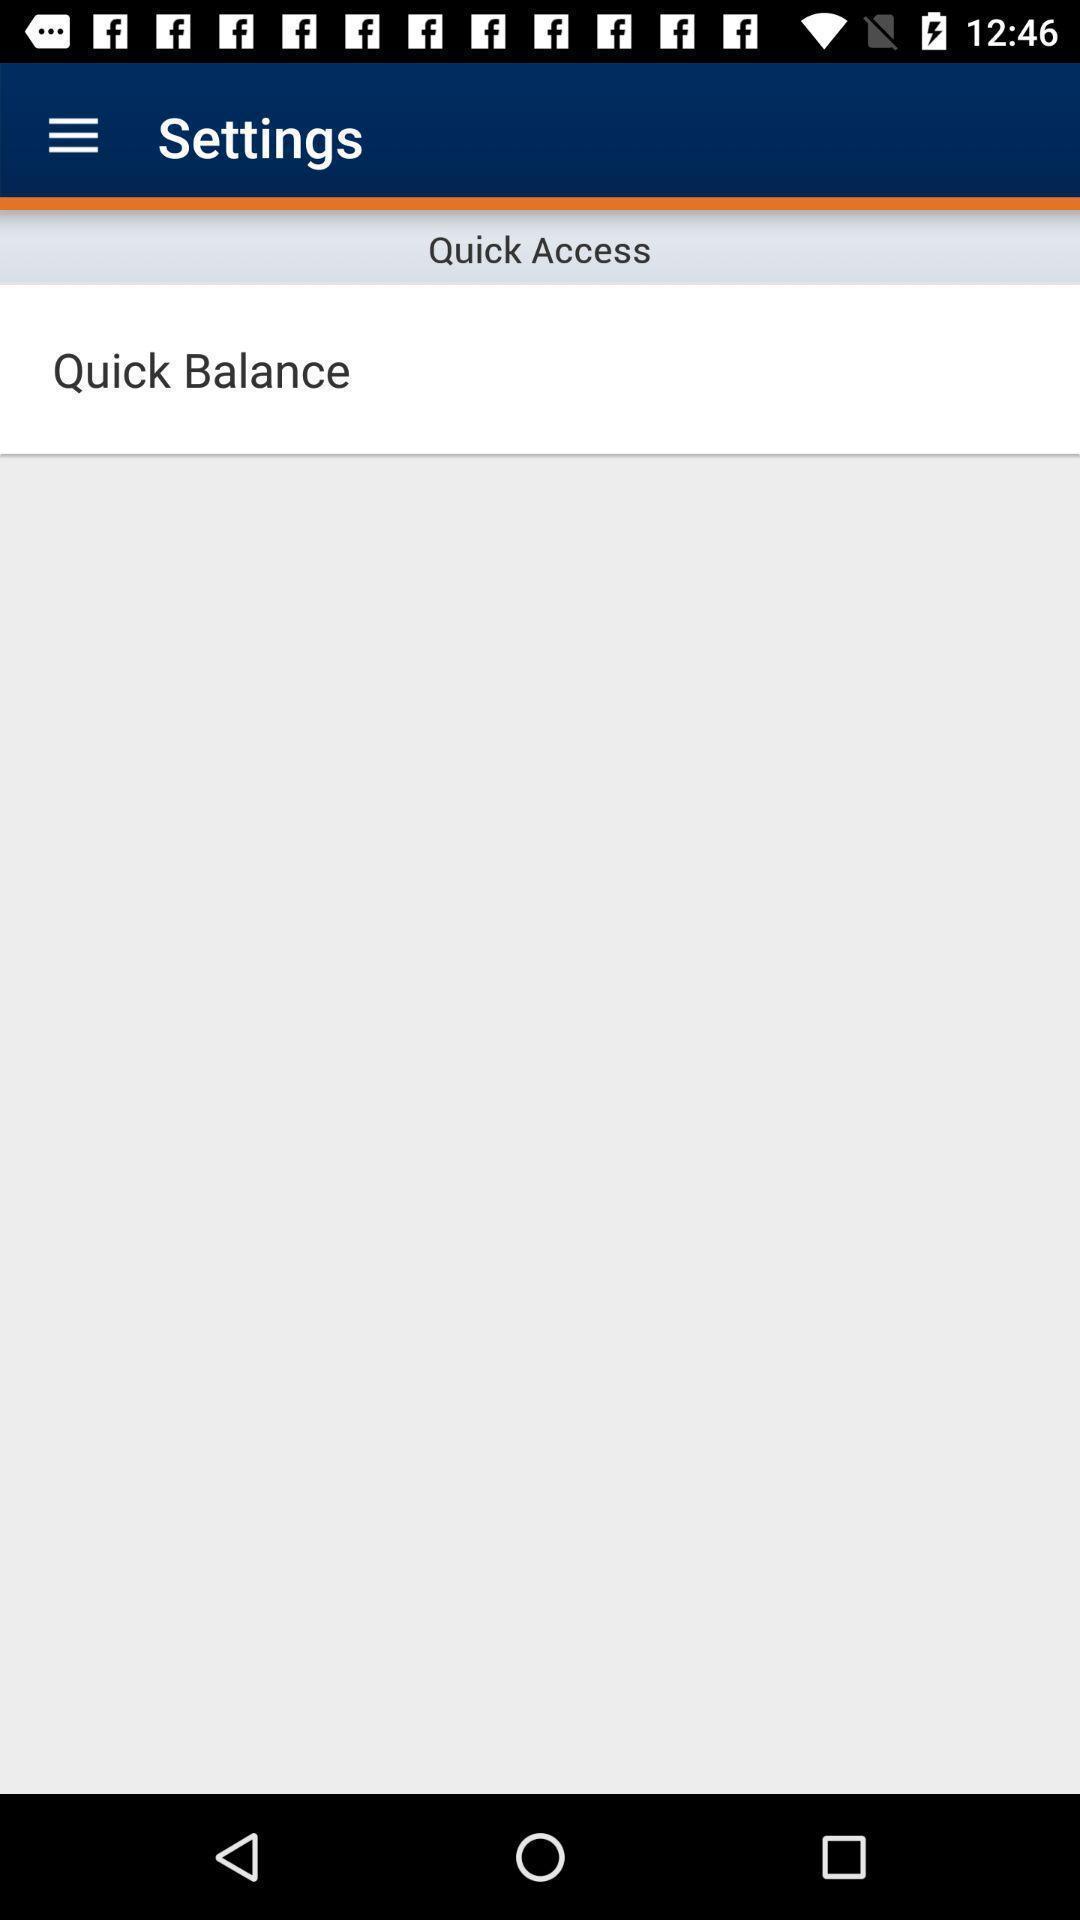Give me a summary of this screen capture. Settings page of a banking app. 